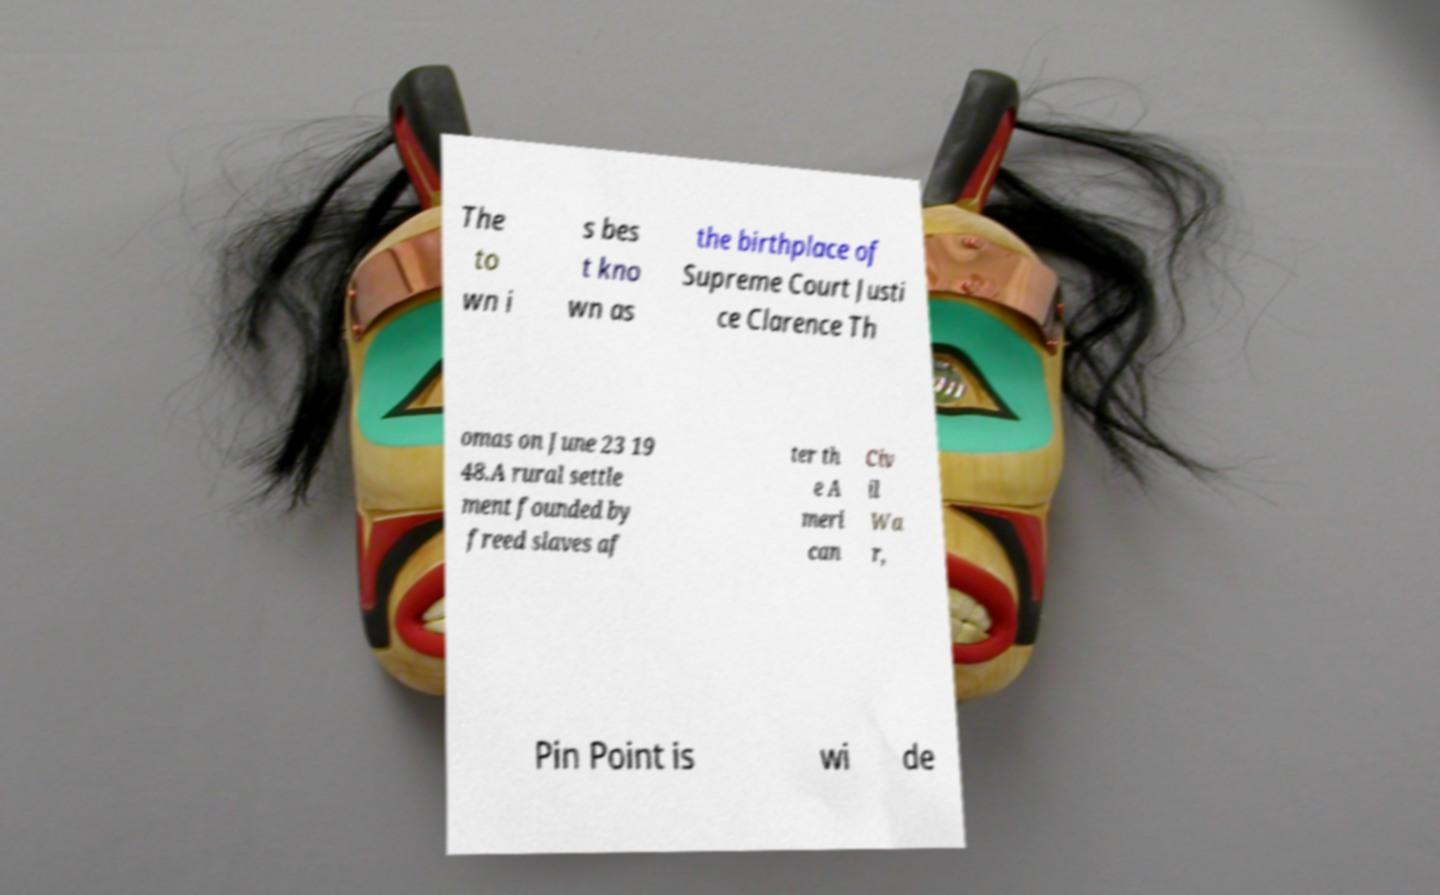What messages or text are displayed in this image? I need them in a readable, typed format. The to wn i s bes t kno wn as the birthplace of Supreme Court Justi ce Clarence Th omas on June 23 19 48.A rural settle ment founded by freed slaves af ter th e A meri can Civ il Wa r, Pin Point is wi de 